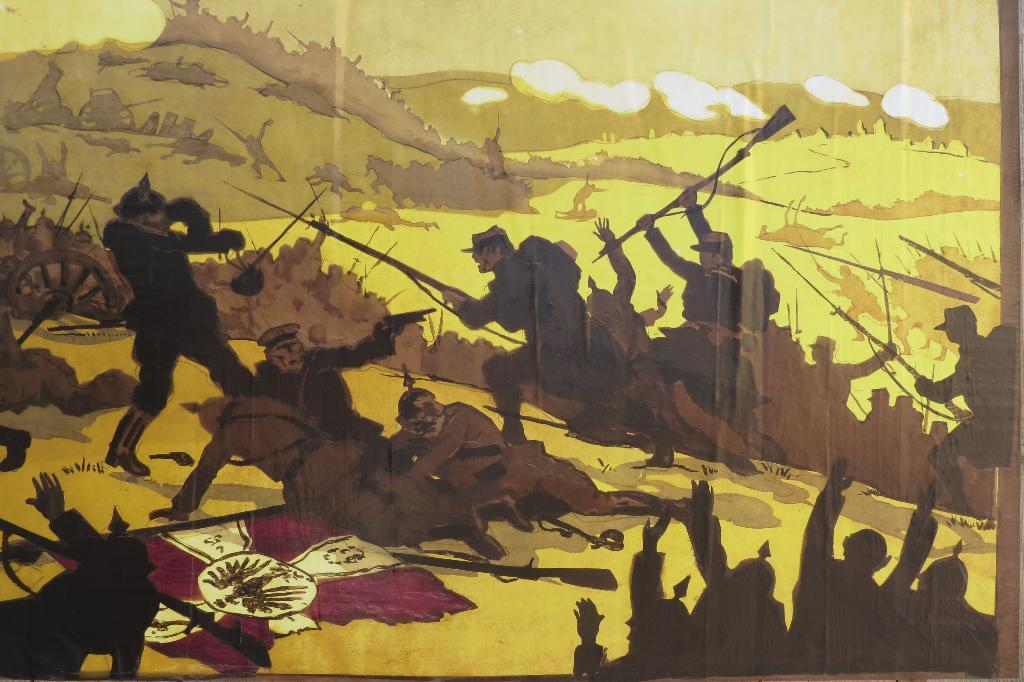What type of artwork is depicted in the image? The image is a painting. Can you describe the main subject of the painting? There are people in the center of the painting. What type of thread is being used by the doctor in the painting? There is no doctor or thread present in the painting; it only features people in the center. 